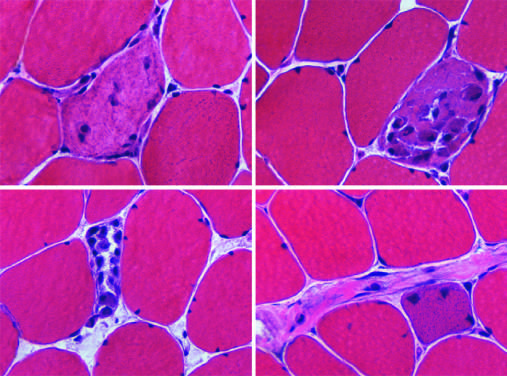what are characterized by cytoplasmic basophilia and enlarged nucleoli (not visible at this power)?
Answer the question using a single word or phrase. Regenerative myofibers 